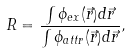<formula> <loc_0><loc_0><loc_500><loc_500>R = \frac { \int \phi _ { e x } ( \vec { r } ) d \vec { r } } { \int \phi _ { a t t r } ( \vec { r } ) d \vec { r } } ,</formula> 